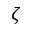<formula> <loc_0><loc_0><loc_500><loc_500>\zeta</formula> 